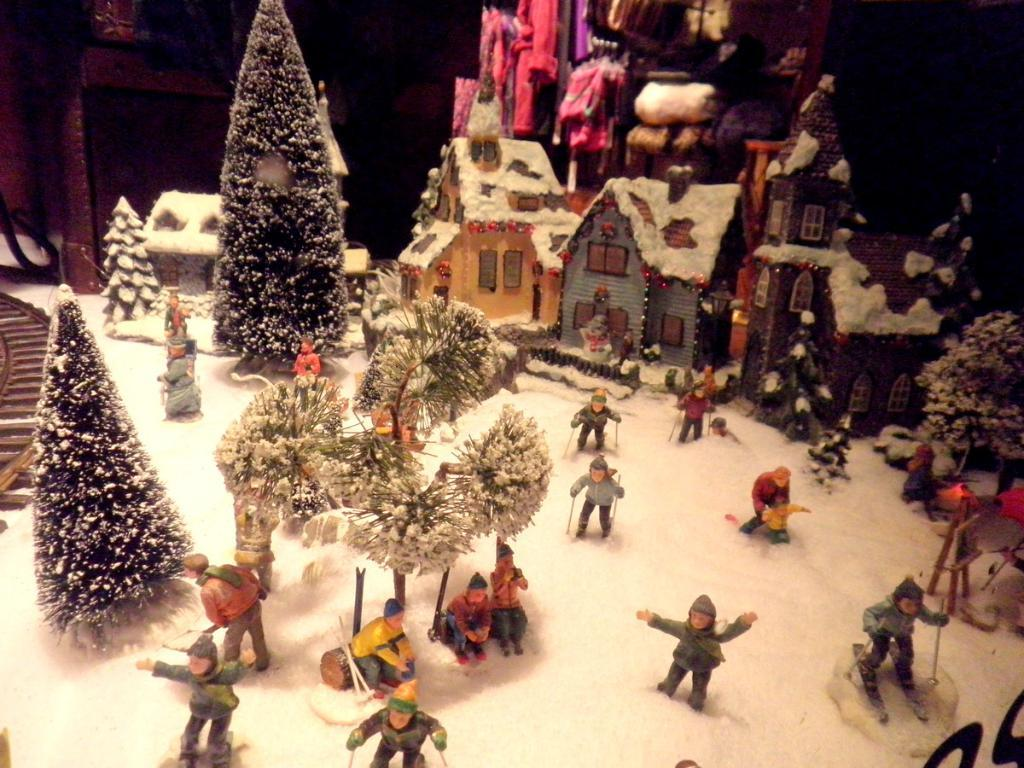What is located at the bottom of the image? Toys, snow, houses, trees, and stairs are located at the bottom of the image. How are the elements at the bottom of the image affected by the snow? All elements at the bottom of the image are covered with snow. Can you describe the background of the image? There are houses in the background of the image. What type of list can be seen in the image? There is no list present in the image. What song is being played in the background of the image? There is no mention of any song or audio in the provided facts, so it cannot be determined from the image. 